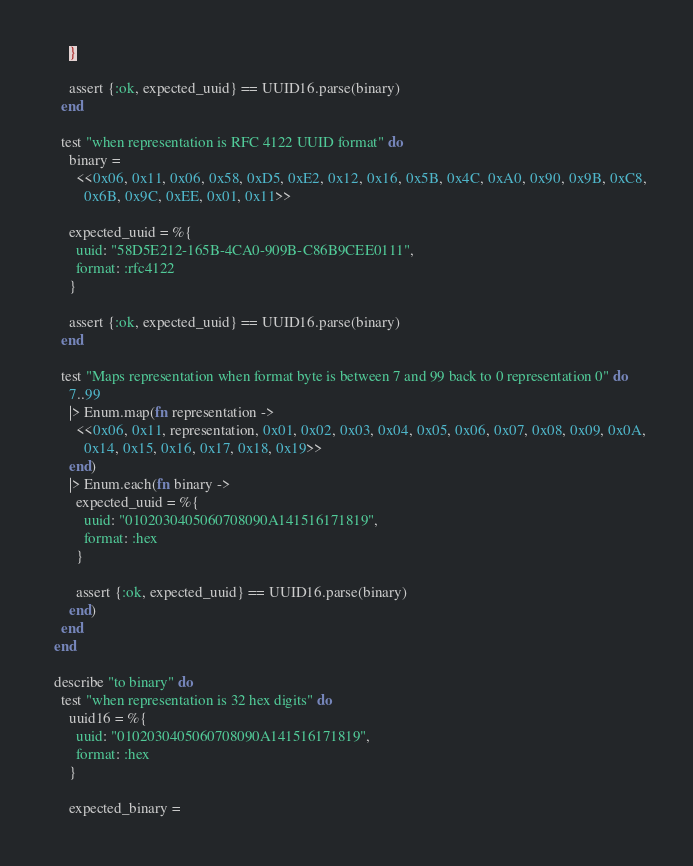Convert code to text. <code><loc_0><loc_0><loc_500><loc_500><_Elixir_>      }

      assert {:ok, expected_uuid} == UUID16.parse(binary)
    end

    test "when representation is RFC 4122 UUID format" do
      binary =
        <<0x06, 0x11, 0x06, 0x58, 0xD5, 0xE2, 0x12, 0x16, 0x5B, 0x4C, 0xA0, 0x90, 0x9B, 0xC8,
          0x6B, 0x9C, 0xEE, 0x01, 0x11>>

      expected_uuid = %{
        uuid: "58D5E212-165B-4CA0-909B-C86B9CEE0111",
        format: :rfc4122
      }

      assert {:ok, expected_uuid} == UUID16.parse(binary)
    end

    test "Maps representation when format byte is between 7 and 99 back to 0 representation 0" do
      7..99
      |> Enum.map(fn representation ->
        <<0x06, 0x11, representation, 0x01, 0x02, 0x03, 0x04, 0x05, 0x06, 0x07, 0x08, 0x09, 0x0A,
          0x14, 0x15, 0x16, 0x17, 0x18, 0x19>>
      end)
      |> Enum.each(fn binary ->
        expected_uuid = %{
          uuid: "0102030405060708090A141516171819",
          format: :hex
        }

        assert {:ok, expected_uuid} == UUID16.parse(binary)
      end)
    end
  end

  describe "to binary" do
    test "when representation is 32 hex digits" do
      uuid16 = %{
        uuid: "0102030405060708090A141516171819",
        format: :hex
      }

      expected_binary =</code> 